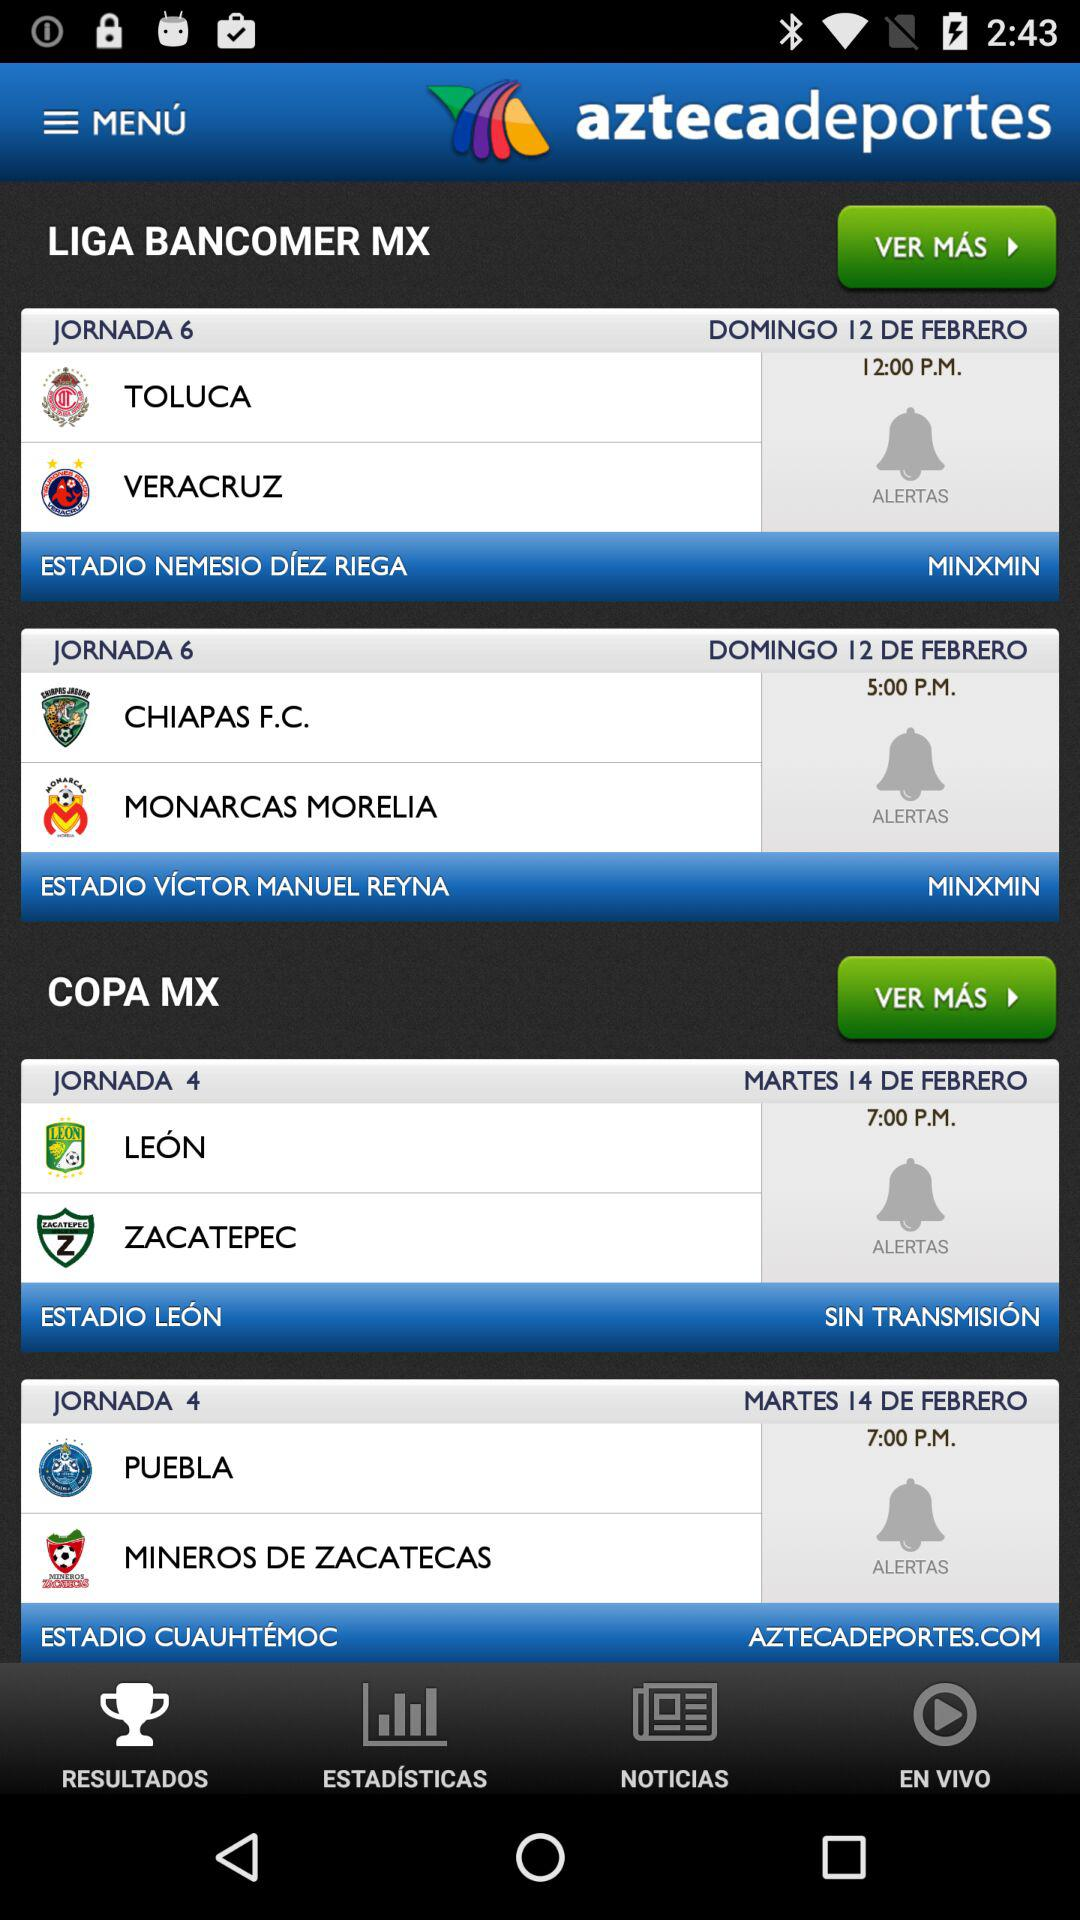How many more matches are in Liga MX than Copa MX?
Answer the question using a single word or phrase. 2 